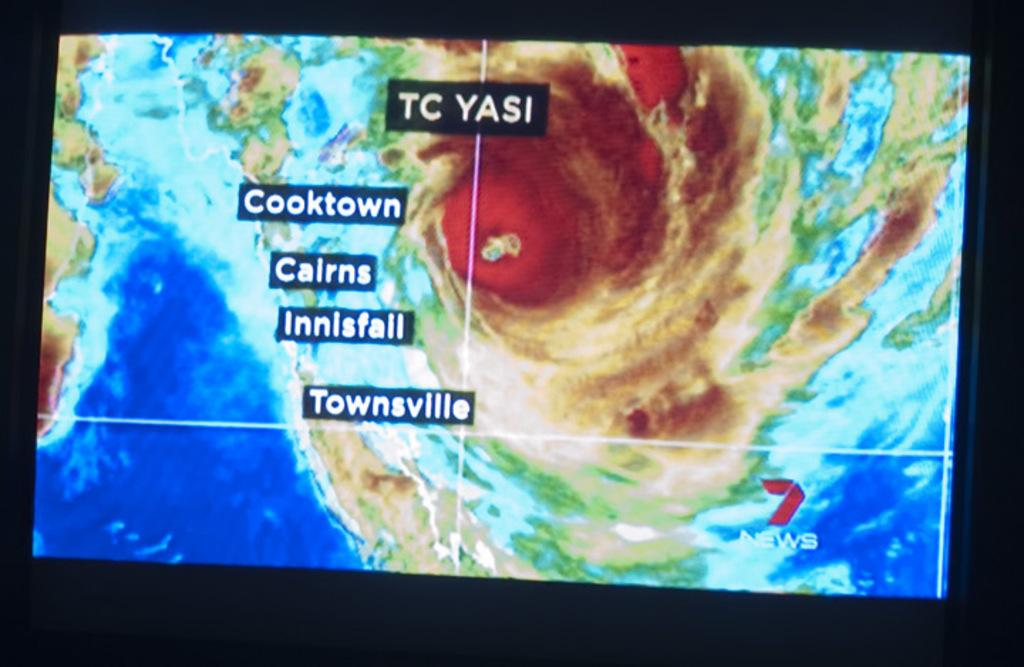<image>
Present a compact description of the photo's key features. a weather scan of someplace in TC Yasi, Cooktown and Cairns included. 